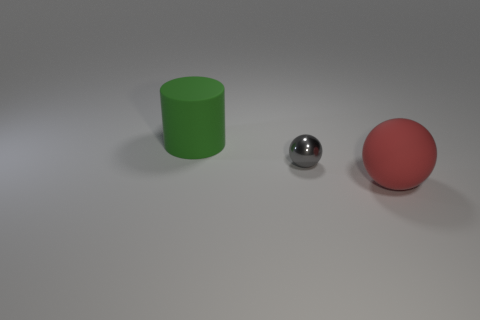How might the lighting direction impact the appearance of these objects? The lighting in the image appears to be coming from the top-right direction. This affects the appearance by creating a bright spot and casting subtle shadows on the side of the objects opposite the light source. The silver sphere reflects this light prominently, while the matte surface of the red ball and the green cylinder shows the illumination more subtly. 